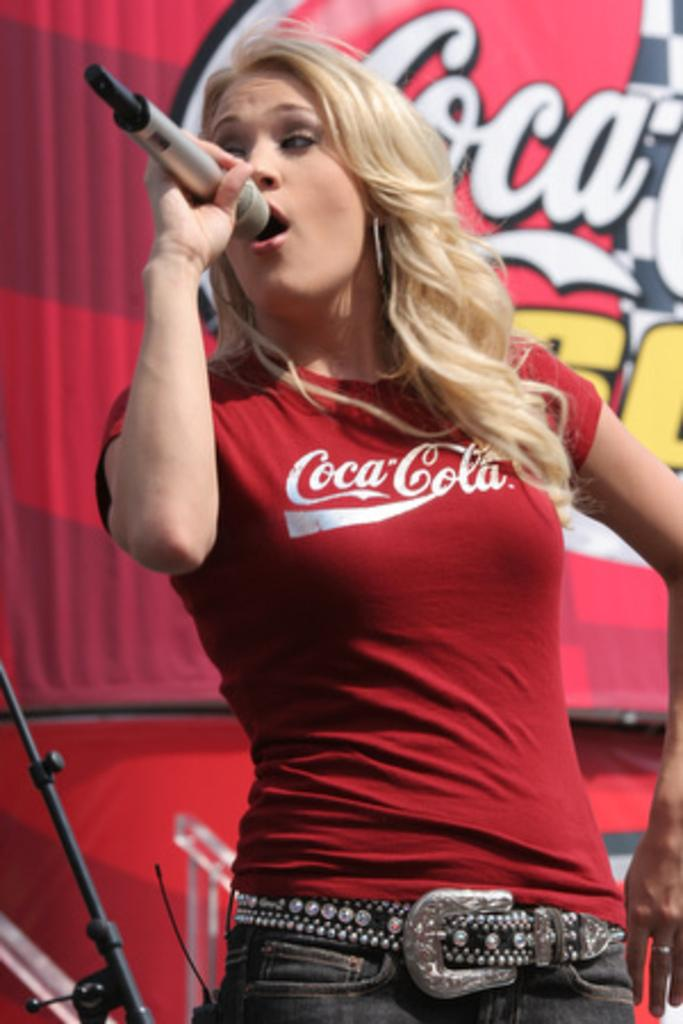Who is the main subject in the image? There is a woman in the image. What is the woman wearing? The woman is wearing a red shirt. What is written on the shirt? The shirt has "Coco Cola" written on it. What is the woman doing in the image? The woman is standing and singing. What is she using to amplify her voice? She is in front of a microphone. What can be seen in the background of the image? There is a red object with writing in the background. Can you see any sticks or mountains in the image? No, there are no sticks or mountains present in the image. Is there an icicle hanging from the microphone in the image? No, there is no icicle present in the image. 